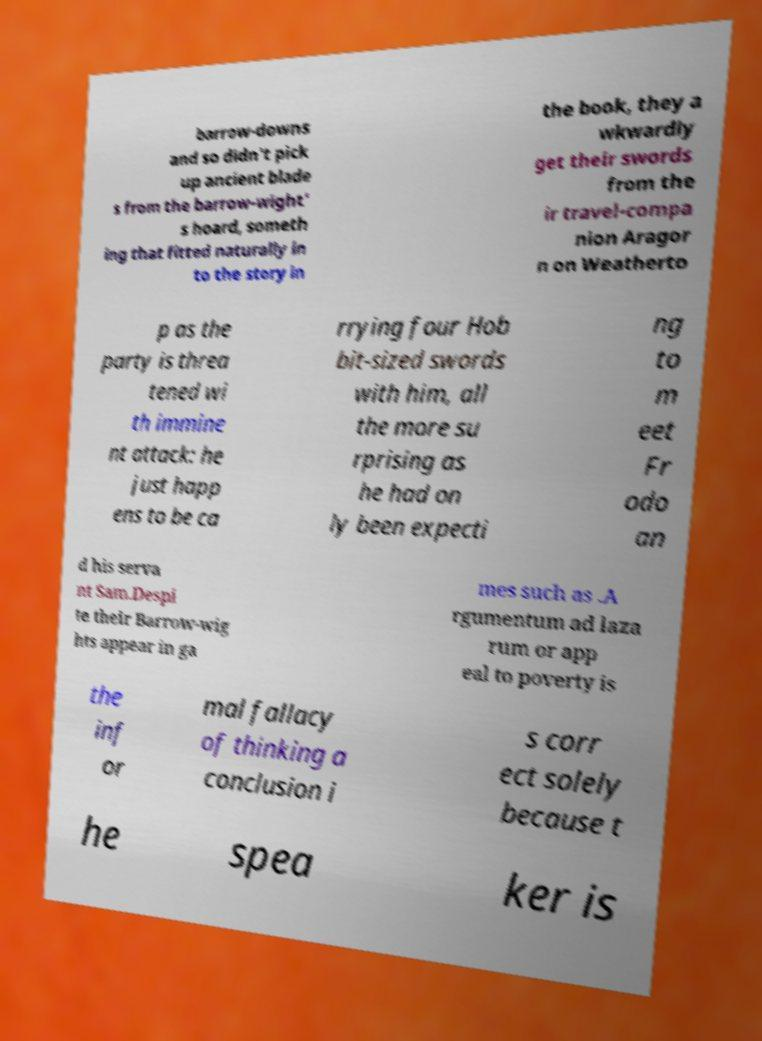Please read and relay the text visible in this image. What does it say? barrow-downs and so didn't pick up ancient blade s from the barrow-wight' s hoard, someth ing that fitted naturally in to the story in the book, they a wkwardly get their swords from the ir travel-compa nion Aragor n on Weatherto p as the party is threa tened wi th immine nt attack: he just happ ens to be ca rrying four Hob bit-sized swords with him, all the more su rprising as he had on ly been expecti ng to m eet Fr odo an d his serva nt Sam.Despi te their Barrow-wig hts appear in ga mes such as .A rgumentum ad laza rum or app eal to poverty is the inf or mal fallacy of thinking a conclusion i s corr ect solely because t he spea ker is 